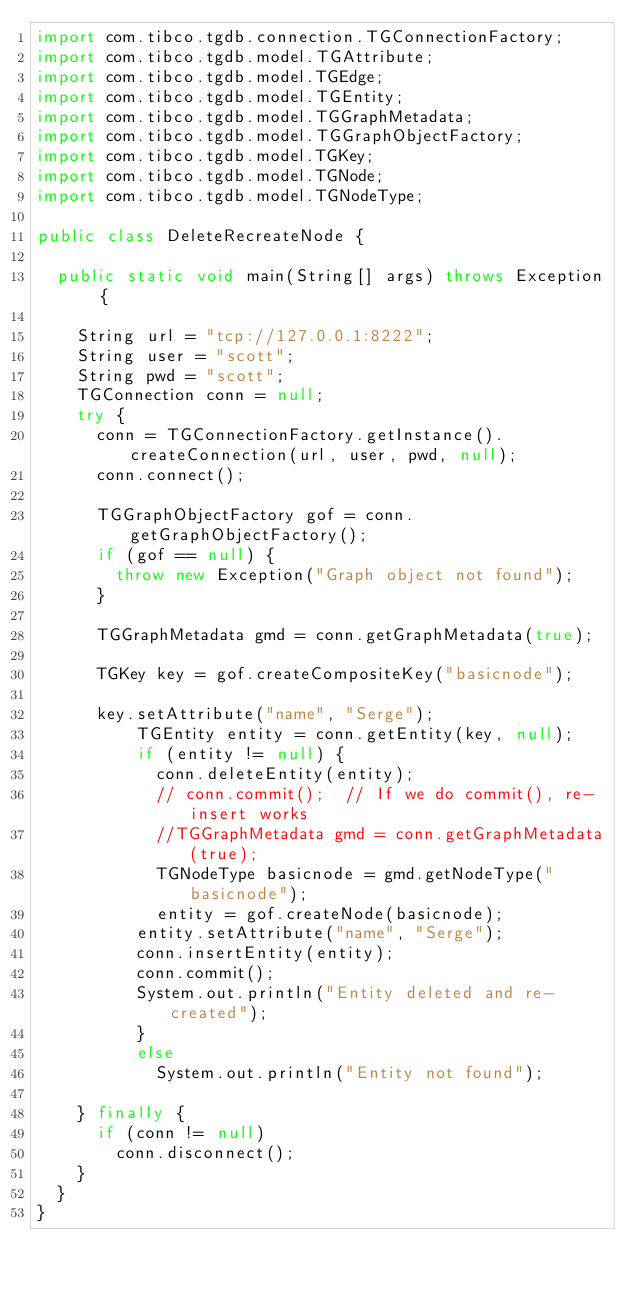Convert code to text. <code><loc_0><loc_0><loc_500><loc_500><_Java_>import com.tibco.tgdb.connection.TGConnectionFactory;
import com.tibco.tgdb.model.TGAttribute;
import com.tibco.tgdb.model.TGEdge;
import com.tibco.tgdb.model.TGEntity;
import com.tibco.tgdb.model.TGGraphMetadata;
import com.tibco.tgdb.model.TGGraphObjectFactory;
import com.tibco.tgdb.model.TGKey;
import com.tibco.tgdb.model.TGNode;
import com.tibco.tgdb.model.TGNodeType;

public class DeleteRecreateNode {

	public static void main(String[] args) throws Exception {

		String url = "tcp://127.0.0.1:8222";
		String user = "scott";
		String pwd = "scott";
		TGConnection conn = null;
		try {
			conn = TGConnectionFactory.getInstance().createConnection(url, user, pwd, null);
			conn.connect();

			TGGraphObjectFactory gof = conn.getGraphObjectFactory();
			if (gof == null) {
				throw new Exception("Graph object not found");
			}
			
			TGGraphMetadata gmd = conn.getGraphMetadata(true);
			
			TGKey key = gof.createCompositeKey("basicnode");
			
			key.setAttribute("name", "Serge");
      		TGEntity entity = conn.getEntity(key, null);
      		if (entity != null) {
      			conn.deleteEntity(entity);
      			// conn.commit();  // If we do commit(), re-insert works
      			//TGGraphMetadata gmd = conn.getGraphMetadata(true);
      			TGNodeType basicnode = gmd.getNodeType("basicnode");
      			entity = gof.createNode(basicnode);
    			entity.setAttribute("name", "Serge");
    			conn.insertEntity(entity);
    			conn.commit();
    			System.out.println("Entity deleted and re-created");
      		}
      		else
      			System.out.println("Entity not found");
      		
		} finally {
			if (conn != null)
				conn.disconnect();
		}
	}
}
</code> 